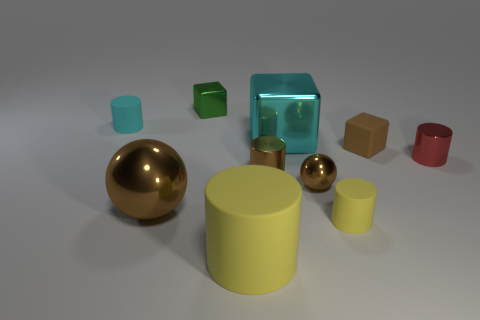What shape is the tiny green thing?
Offer a very short reply. Cube. What shape is the cyan thing that is in front of the small object that is left of the green thing?
Make the answer very short. Cube. There is a block that is the same color as the big shiny sphere; what is it made of?
Provide a short and direct response. Rubber. The big cylinder that is the same material as the tiny brown block is what color?
Ensure brevity in your answer.  Yellow. There is a rubber cylinder that is left of the big cylinder; is it the same color as the big metal object that is to the right of the tiny green thing?
Your answer should be very brief. Yes. Is the number of brown metallic cylinders behind the tiny rubber block greater than the number of small cyan cylinders that are to the right of the tiny brown metallic ball?
Offer a very short reply. No. What color is the tiny object that is the same shape as the large brown object?
Ensure brevity in your answer.  Brown. Is the shape of the tiny yellow matte object the same as the large brown shiny object that is in front of the tiny red cylinder?
Keep it short and to the point. No. How many other objects are there of the same material as the cyan block?
Your answer should be compact. 5. There is a big metal ball; does it have the same color as the tiny rubber thing in front of the brown rubber object?
Keep it short and to the point. No. 